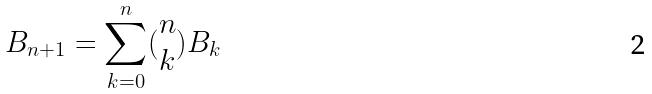<formula> <loc_0><loc_0><loc_500><loc_500>B _ { n + 1 } = \sum _ { k = 0 } ^ { n } ( \begin{matrix} n \\ k \end{matrix} ) B _ { k }</formula> 